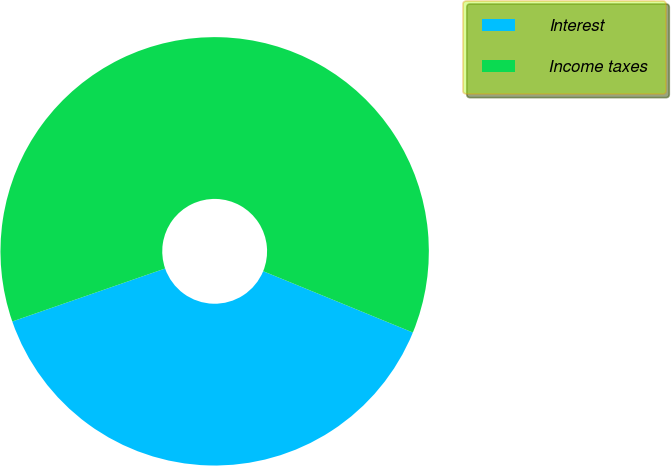Convert chart. <chart><loc_0><loc_0><loc_500><loc_500><pie_chart><fcel>Interest<fcel>Income taxes<nl><fcel>38.5%<fcel>61.5%<nl></chart> 